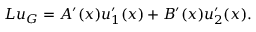Convert formula to latex. <formula><loc_0><loc_0><loc_500><loc_500>L u _ { G } = A ^ { \prime } ( x ) u _ { 1 } ^ { \prime } ( x ) + B ^ { \prime } ( x ) u _ { 2 } ^ { \prime } ( x ) .</formula> 